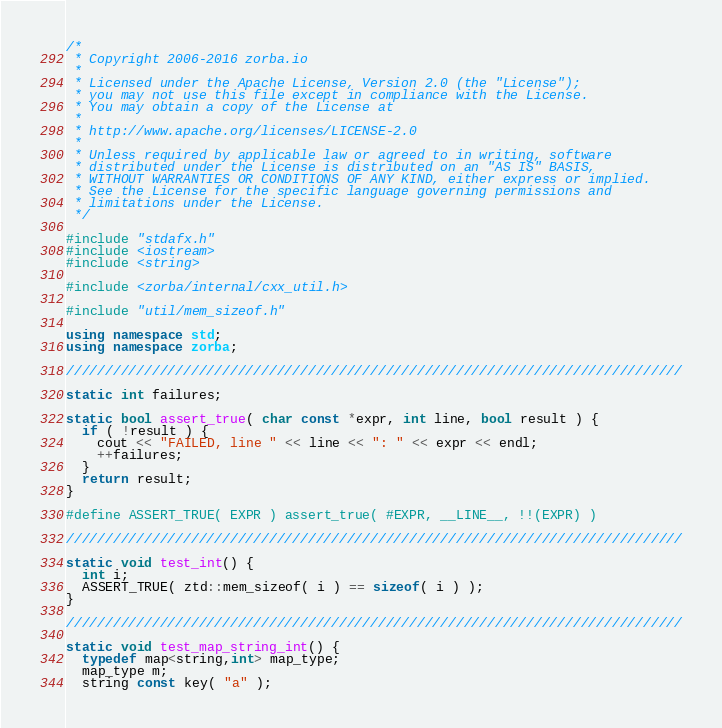Convert code to text. <code><loc_0><loc_0><loc_500><loc_500><_C++_>/*
 * Copyright 2006-2016 zorba.io
 * 
 * Licensed under the Apache License, Version 2.0 (the "License");
 * you may not use this file except in compliance with the License.
 * You may obtain a copy of the License at
 * 
 * http://www.apache.org/licenses/LICENSE-2.0
 * 
 * Unless required by applicable law or agreed to in writing, software
 * distributed under the License is distributed on an "AS IS" BASIS,
 * WITHOUT WARRANTIES OR CONDITIONS OF ANY KIND, either express or implied.
 * See the License for the specific language governing permissions and
 * limitations under the License.
 */

#include "stdafx.h"
#include <iostream>
#include <string>

#include <zorba/internal/cxx_util.h>

#include "util/mem_sizeof.h"

using namespace std;
using namespace zorba;

///////////////////////////////////////////////////////////////////////////////

static int failures;

static bool assert_true( char const *expr, int line, bool result ) {
  if ( !result ) {
    cout << "FAILED, line " << line << ": " << expr << endl;
    ++failures;
  }
  return result;
}

#define ASSERT_TRUE( EXPR ) assert_true( #EXPR, __LINE__, !!(EXPR) )

///////////////////////////////////////////////////////////////////////////////

static void test_int() {
  int i;
  ASSERT_TRUE( ztd::mem_sizeof( i ) == sizeof( i ) );
}

///////////////////////////////////////////////////////////////////////////////

static void test_map_string_int() {
  typedef map<string,int> map_type;
  map_type m;
  string const key( "a" );</code> 